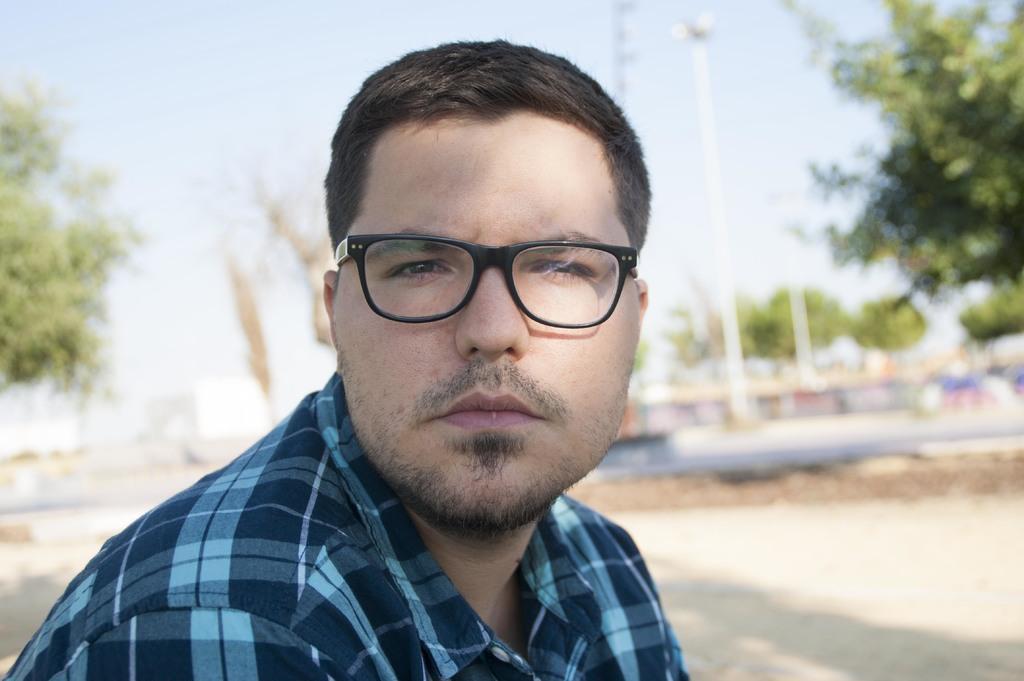Can you describe this image briefly? In this image, we can see a man is wearing a shirt and glasses. Here is seeing. Background we can see a blur view. Here we can see few trees, poles, ground and sky. 